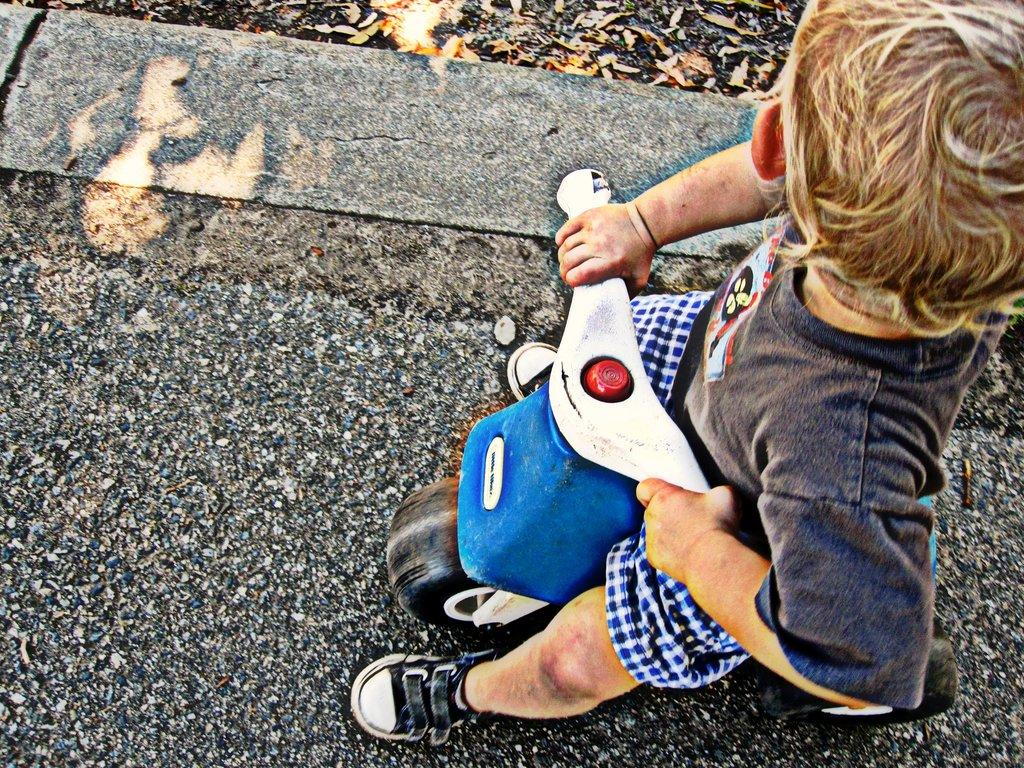Who is the main subject in the image? There is a boy in the image. What is the boy doing in the image? The boy is sitting on a toy vehicle. What can be seen in the background of the image? There are dry leaves in the background of the image. What type of chalk is the boy using to draw on the seashore in the image? There is no seashore or chalk present in the image; it features a boy sitting on a toy vehicle with dry leaves in the background. 